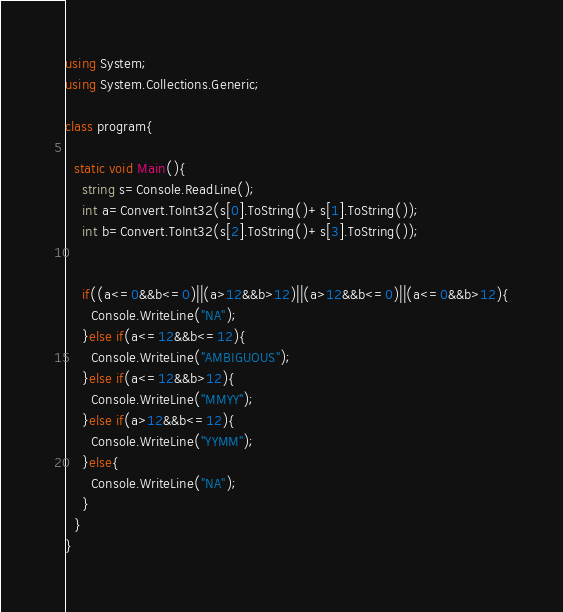Convert code to text. <code><loc_0><loc_0><loc_500><loc_500><_C#_>using System;
using System.Collections.Generic;

class program{

  static void Main(){
    string s=Console.ReadLine();
    int a=Convert.ToInt32(s[0].ToString()+s[1].ToString());
    int b=Convert.ToInt32(s[2].ToString()+s[3].ToString());
  
  
    if((a<=0&&b<=0)||(a>12&&b>12)||(a>12&&b<=0)||(a<=0&&b>12){
      Console.WriteLine("NA"); 
    }else if(a<=12&&b<=12){
      Console.WriteLine("AMBIGUOUS");
    }else if(a<=12&&b>12){
      Console.WriteLine("MMYY"); 
    }else if(a>12&&b<=12){
      Console.WriteLine("YYMM"); 
    }else{
      Console.WriteLine("NA"); 
    }
  }
}


</code> 